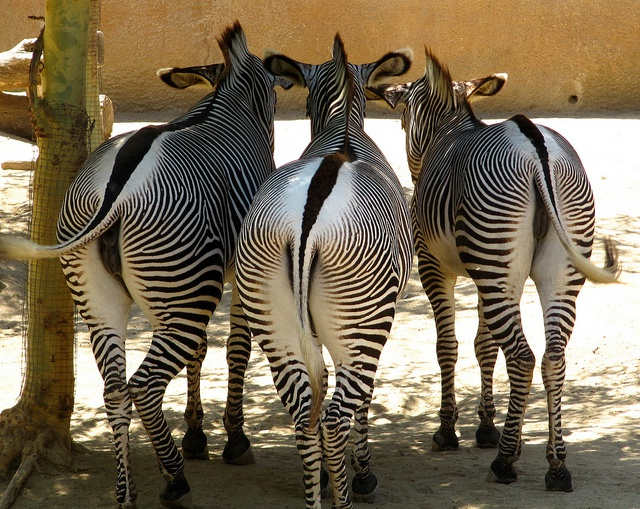Describe the objects in this image and their specific colors. I can see zebra in olive, black, gray, tan, and darkgray tones, zebra in olive, black, darkgray, tan, and gray tones, and zebra in olive, black, gray, and darkgray tones in this image. 